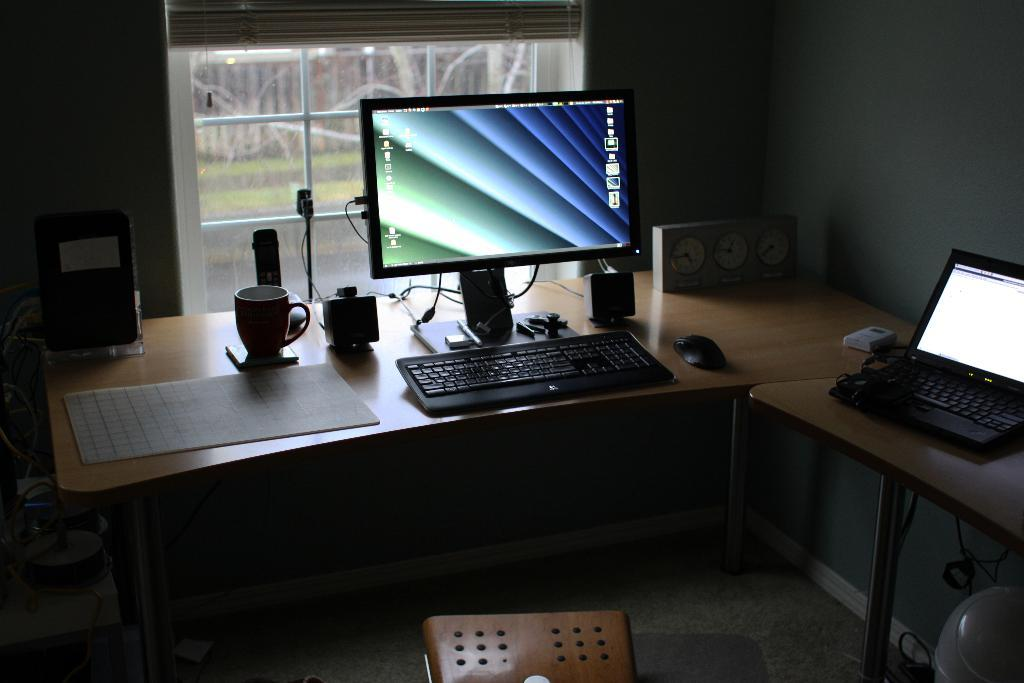What is the main piece of furniture in the image? There is a table in the image. What is placed on the table? There is a paper, a cup, speakers, a keyboard, a monitor, a mouse, a remote, and a laptop on the table. Can you describe the window in the background of the image? There is a window in the background of the image, but no specific details about the window are provided. What type of voyage is being planned on the table in the image? There is no indication of a voyage being planned in the image; the table contains various objects, including a keyboard, a monitor, and a laptop, but no specific activity related to a voyage is depicted. 